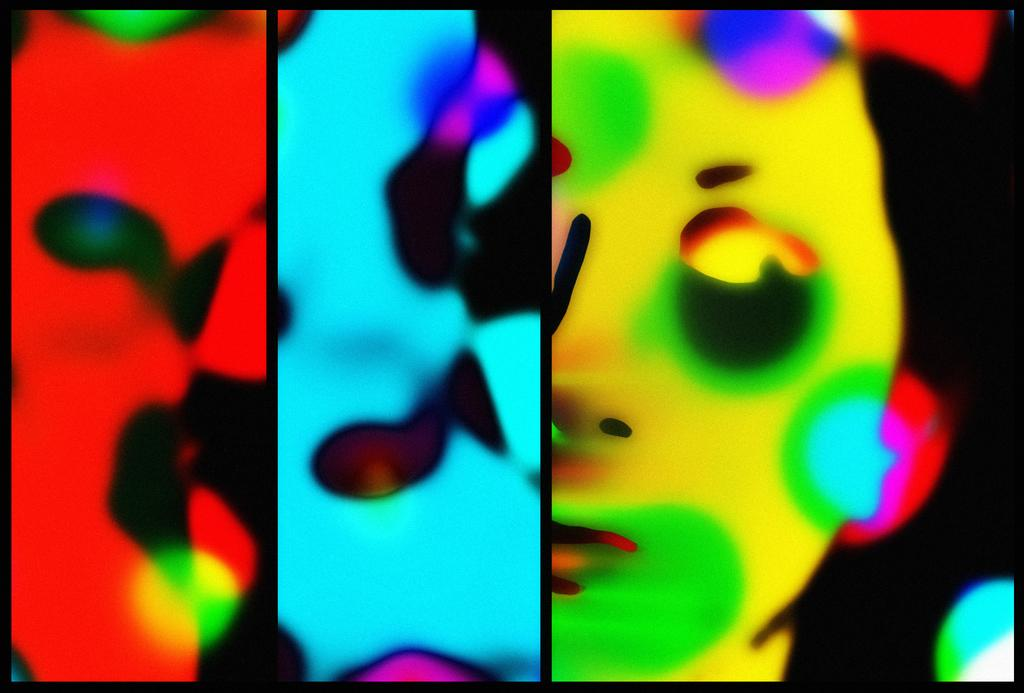What type of image is being described? The image is a collage. What can be seen within the collage? There is an animation of a person in the image. How many beds are visible in the image? There are no beds present in the image, as it is a collage with an animation of a person. What type of net is being used by the person in the image? There is no net visible in the image; it only features an animation of a person. 